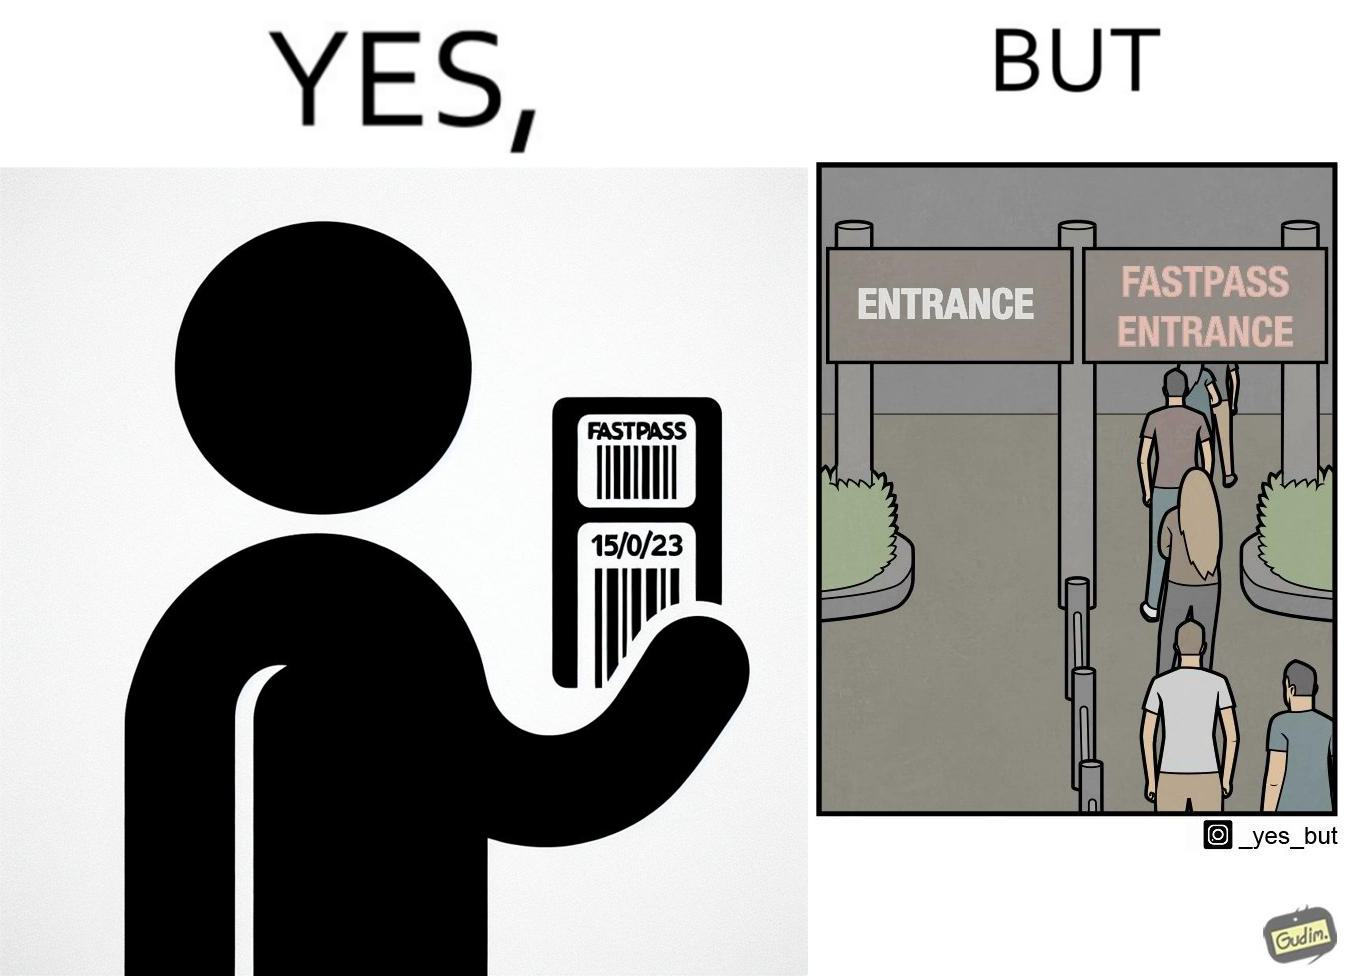Is this image satirical or non-satirical? Yes, this image is satirical. 